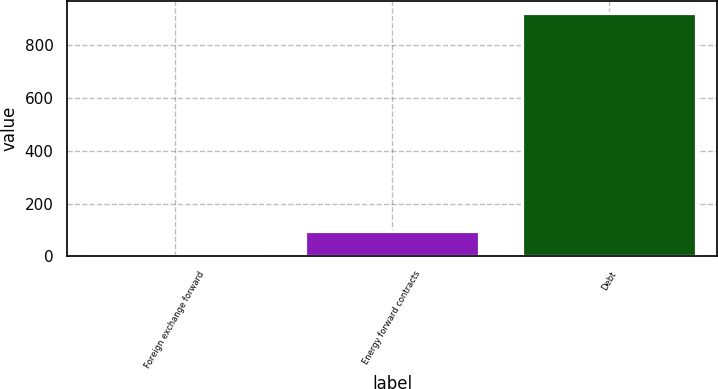Convert chart. <chart><loc_0><loc_0><loc_500><loc_500><bar_chart><fcel>Foreign exchange forward<fcel>Energy forward contracts<fcel>Debt<nl><fcel>3.2<fcel>95.23<fcel>923.5<nl></chart> 